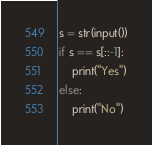Convert code to text. <code><loc_0><loc_0><loc_500><loc_500><_Python_>s = str(input())
if s == s[::-1]:
	print("Yes")
else:
	print("No")</code> 